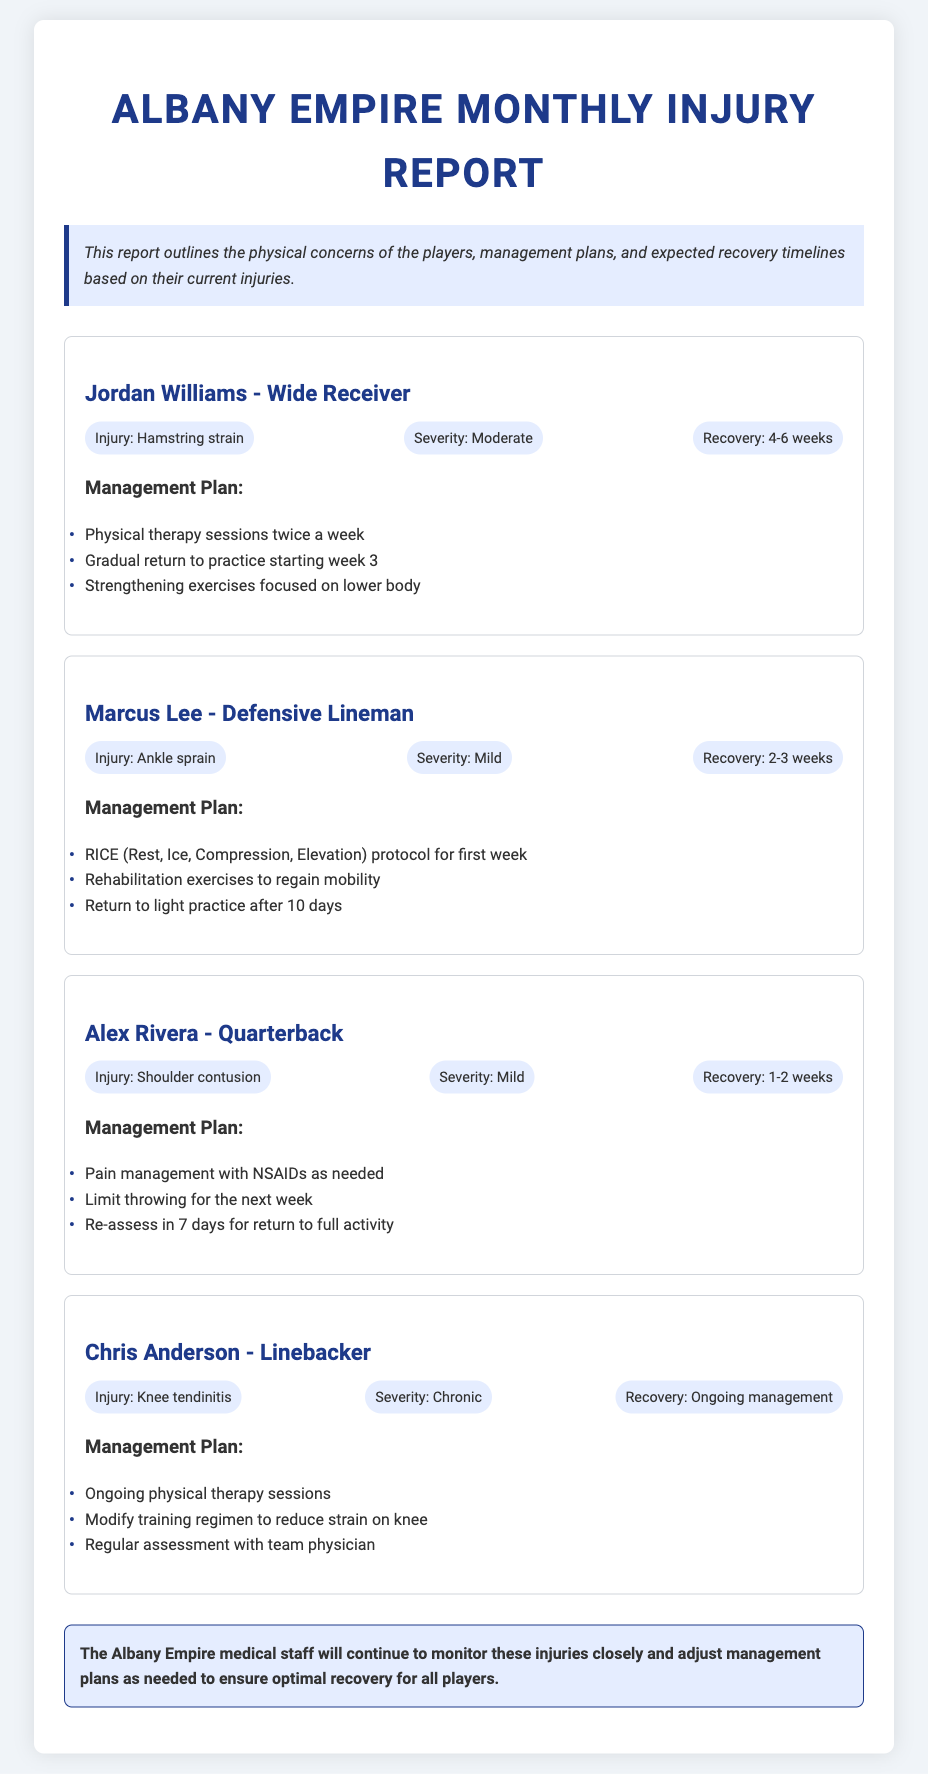What is the injury of Jordan Williams? Jordan Williams has a hamstring strain, as stated in the injury report.
Answer: Hamstring strain What is the recovery time for Marcus Lee's ankle sprain? The recovery time mentioned for Marcus Lee's ankle sprain is between 2 to 3 weeks.
Answer: 2-3 weeks What management plan is Alex Rivera following? Alex Rivera's management plan includes pain management with NSAIDs as needed, limiting throwing for the next week, and re-assessing in 7 days.
Answer: Pain management, limit throwing What is the severity of Chris Anderson's injury? Chris Anderson's injury severity is labeled as chronic in the report.
Answer: Chronic How many physical therapy sessions per week is Jordan Williams receiving? Jordan Williams is scheduled for physical therapy sessions twice a week according to his management plan.
Answer: Twice a week What type of injury does Marcus Lee have? Marcus Lee's type of injury is classified as an ankle sprain in the report.
Answer: Ankle sprain What ongoing management is needed for Chris Anderson's knee tendinitis? Chris Anderson requires ongoing physical therapy sessions as part of the management for his knee tendinitis.
Answer: Ongoing physical therapy How long is Alex Rivera expected to recover? Alex Rivera is expected to recover within 1 to 2 weeks as stated in the injury report.
Answer: 1-2 weeks What protocol is Marcus Lee following for the first week? Marcus Lee follows the RICE protocol (Rest, Ice, Compression, Elevation) during the first week of recovery.
Answer: RICE protocol 